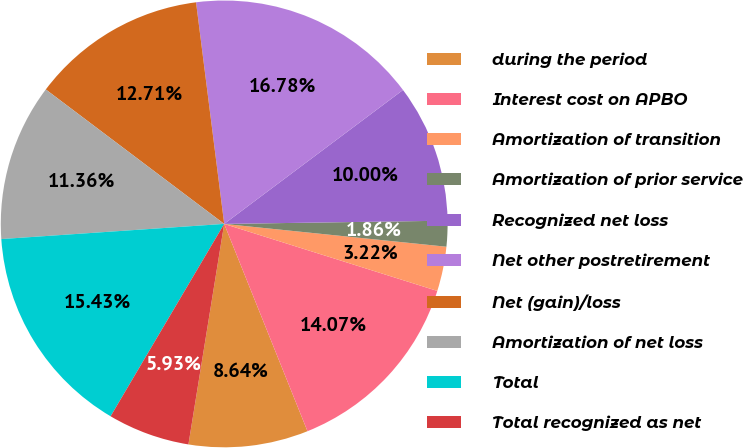Convert chart to OTSL. <chart><loc_0><loc_0><loc_500><loc_500><pie_chart><fcel>during the period<fcel>Interest cost on APBO<fcel>Amortization of transition<fcel>Amortization of prior service<fcel>Recognized net loss<fcel>Net other postretirement<fcel>Net (gain)/loss<fcel>Amortization of net loss<fcel>Total<fcel>Total recognized as net<nl><fcel>8.64%<fcel>14.07%<fcel>3.22%<fcel>1.86%<fcel>10.0%<fcel>16.78%<fcel>12.71%<fcel>11.36%<fcel>15.43%<fcel>5.93%<nl></chart> 